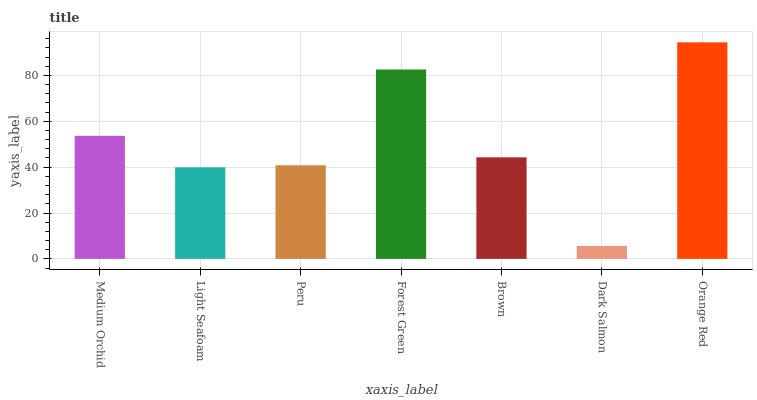Is Light Seafoam the minimum?
Answer yes or no. No. Is Light Seafoam the maximum?
Answer yes or no. No. Is Medium Orchid greater than Light Seafoam?
Answer yes or no. Yes. Is Light Seafoam less than Medium Orchid?
Answer yes or no. Yes. Is Light Seafoam greater than Medium Orchid?
Answer yes or no. No. Is Medium Orchid less than Light Seafoam?
Answer yes or no. No. Is Brown the high median?
Answer yes or no. Yes. Is Brown the low median?
Answer yes or no. Yes. Is Forest Green the high median?
Answer yes or no. No. Is Forest Green the low median?
Answer yes or no. No. 